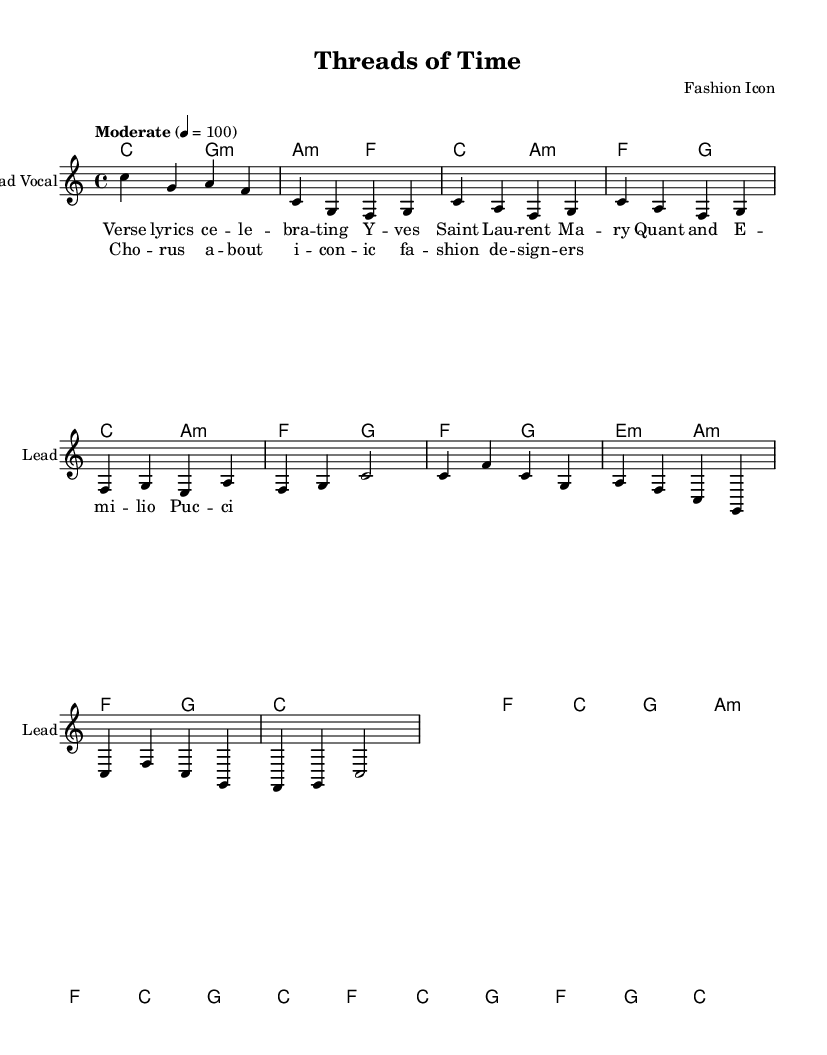What is the key signature of this music? The sheet music indicates that it is in C major, which has no sharps or flats. This is evident from the absence of any sharp or flat symbols at the beginning of the staff.
Answer: C major What is the time signature of this piece? The time signature is given right after the clef at the beginning of the score, which is 4/4. This means there are four beats in each measure and a quarter note gets one beat.
Answer: 4/4 What is the tempo marking for this piece? The tempo marking is located above the staff and states "Moderate" with a beats per minute indication of 100. This provides information on how quickly the piece should be played.
Answer: Moderate 4 = 100 How many measures are in the chorus section? By analyzing the structure provided in the melody and harmony, the chorus repeats with a total of four measures. Each set of chord and melody corresponds to the chorus lyrics, identifiable by their distinct wording.
Answer: Four measures What chord is played during the verse section's first measure? The first measure of the verse corresponds to the chord indicated in the harmonies section, which is C major. It can be confirmed by observing that the chord symbol above the staff is C.
Answer: C major What genre does this piece belong to? The elements in the lyrics, along with the stylistic choices in the harmonies and melodies, point to it being categorized within the Soul genre, particularly drawing inspiration from Classic Motown.
Answer: Soul Which iconic fashion designer is mentioned in the lyrics? The lyrics clearly highlight Yves Saint Laurent as one of the fashion designers celebrated in the verses. The name is explicitly stated in the lyrics section, making it easily identifiable.
Answer: Yves Saint Laurent 